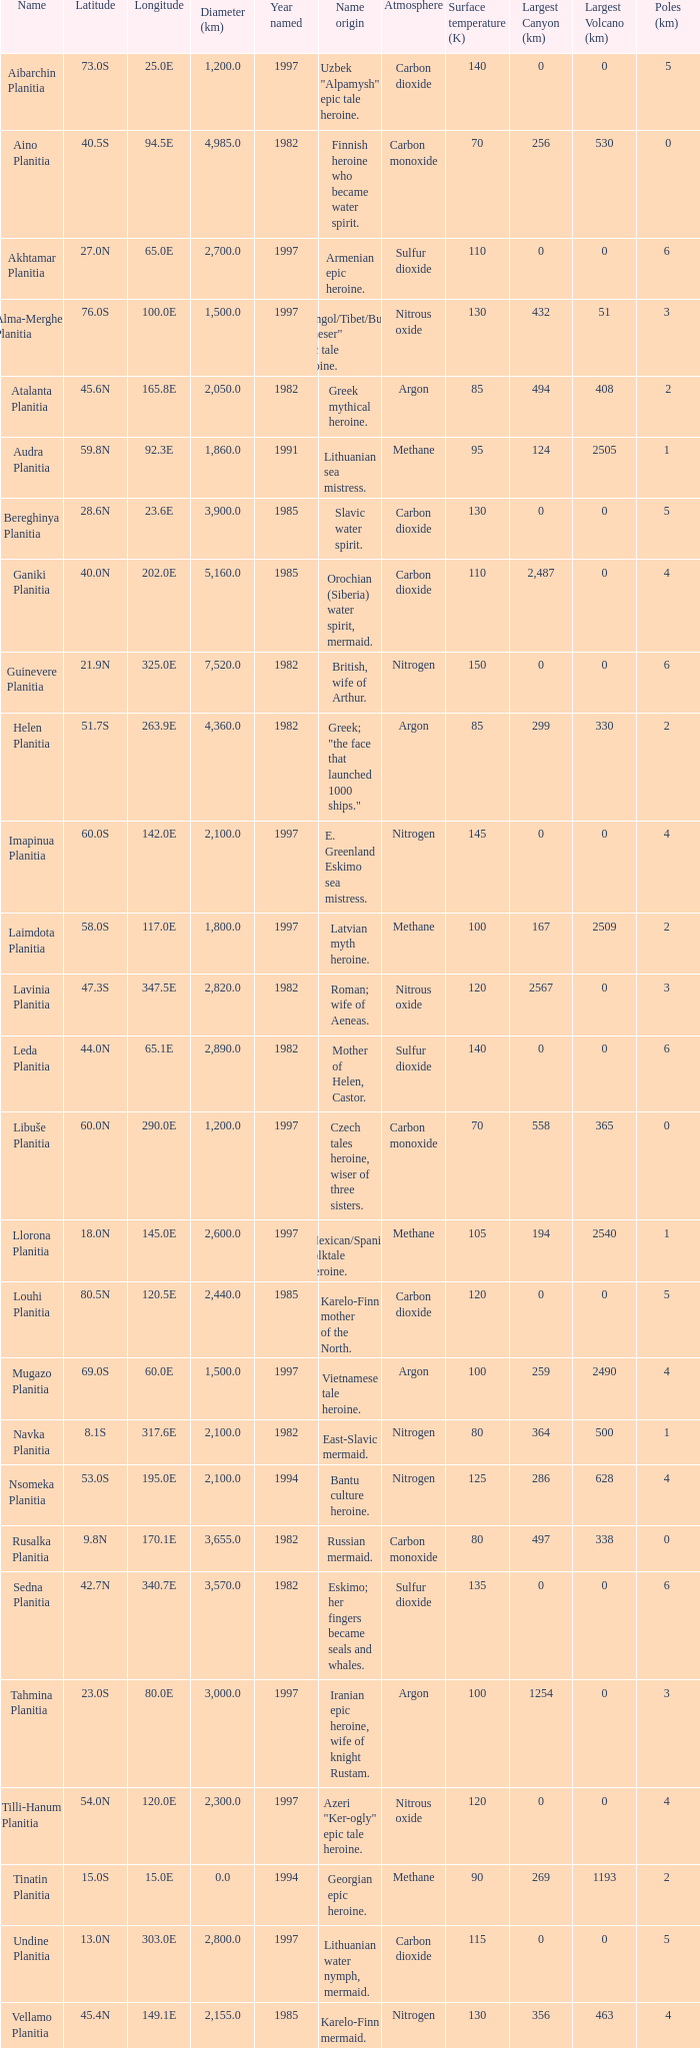What is the latitude of the feature of longitude 80.0e 23.0S. 